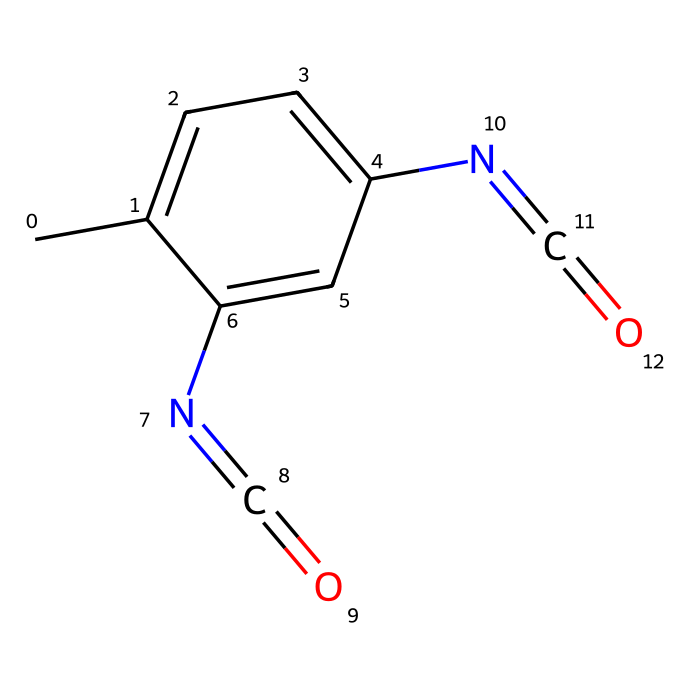What are the primary elements in this chemical structure? The chemical structure contains carbon (C), nitrogen (N), and oxygen (O) as the primary elements. This can be identified from the SMILES representation, which shows carbon atoms (C), highlighted by the presence of 'c' for aromatic carbons, nitrogen atoms seen in '[N]', and oxygen atoms in the isocyanate functional groups represented by '[N]=C=O'.
Answer: carbon, nitrogen, oxygen How many nitrogen atoms are present? Analyzing the SMILES representation reveals two '[N]' notations, indicating there are two nitrogen atoms in the chemical structure.
Answer: two What functional group is indicated by '[N]=C=O'? The '[N]=C=O' part of the SMILES represents an isocyanate functional group since it consists of a nitrogen atom double-bonded to a carbon, which is also double-bonded to an oxygen. This structure typifies isocyanates commonly used in polyurethane chemistry.
Answer: isocyanate What is the total number of rings in this structure? The SMILES notation includes 'c1ccccc', indicating a cyclic structure or benzene ring. Although it is part of a larger structure, there is one aromatic ring identified in this chemical, which is the only ring present.
Answer: one What is the significance of the isocyanate in polyurethane foam production? Isocyanates are crucial in polyurethane foam as they react with polyols to form the polymer network that gives foam its structural properties. This reaction is fundamental in producing flexible and durable materials, like those used in puppet heads.
Answer: reaction with polyol What type of polymerization involves this monomer? The reaction involving this monomer is known as step-growth polymerization. This occurs as isocyanates react with polyols, leading to the formation of a polymer without the elimination of small molecules, which characterizes polyurethane production.
Answer: step-growth polymerization How many double bonds are present in this molecule? By examining the structure closely, specifically in the '[N]=C=O' groups, it is noted that there are two double bonds—one between nitrogen and carbon and another between carbon and oxygen in each isocyanate grouping. Therefore, the total number of double bonds is two.
Answer: two 